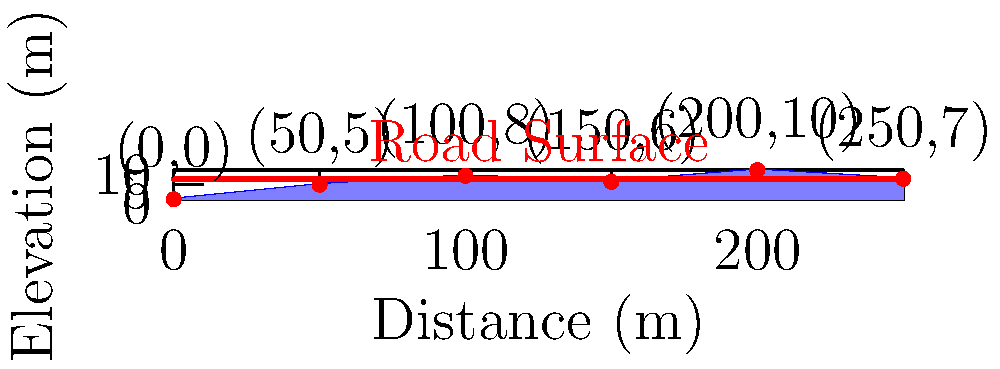A new road is being constructed along a terrain profile as shown in the figure. The road surface is to be built at a constant elevation of 7 meters. Calculate the total volume of earthwork required for this road construction project, assuming the road width is 10 meters and the cross-section remains constant throughout the length. Round your answer to the nearest cubic meter. To calculate the total volume of earthwork, we need to follow these steps:

1) Divide the terrain into sections based on the given data points.

2) Calculate the area of each section that needs to be filled or cut:
   - For sections below 7m: calculate area to be filled
   - For sections above 7m: calculate area to be cut

3) Use the trapezoidal rule to calculate these areas:
   Area = (h1 + h2) * w / 2, where h1 and h2 are the heights at the ends of each section, and w is the width of the section.

4) Multiply each area by the road width (10m) to get the volume for each section.

5) Sum up all volumes.

Let's calculate for each section:

Section 1 (0-50m):
$A_1 = (7-0 + 7-5) * 50 / 2 = 225$ m²
$V_1 = 225 * 10 = 2250$ m³ (fill)

Section 2 (50-100m):
$A_2 = (7-5 + 7-8) * 50 / 2 = 25$ m²
$V_2 = 25 * 10 = 250$ m³ (fill and cut)

Section 3 (100-150m):
$A_3 = (7-8 + 7-6) * 50 / 2 = 0$ m²
$V_3 = 0$ m³ (balanced cut and fill)

Section 4 (150-200m):
$A_4 = (7-6 + 7-10) * 50 / 2 = -50$ m²
$V_4 = 50 * 10 = 500$ m³ (cut)

Section 5 (200-250m):
$A_5 = (7-10 + 7-7) * 50 / 2 = -75$ m²
$V_5 = 75 * 10 = 750$ m³ (cut)

Total volume = $V_1 + V_2 + V_3 + V_4 + V_5$
             = $2250 + 250 + 0 + 500 + 750$
             = $3750$ m³

Rounding to the nearest cubic meter, the answer remains 3750 m³.
Answer: 3750 m³ 